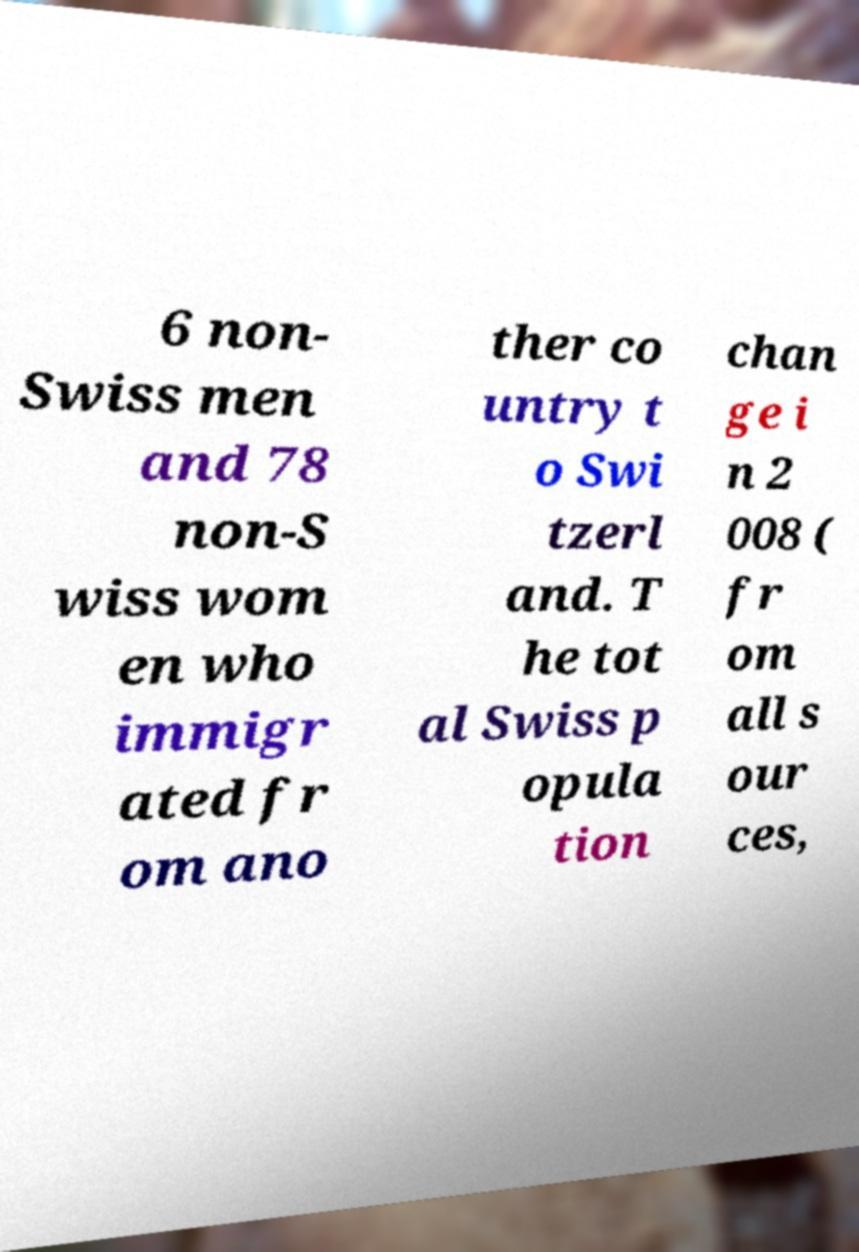Could you assist in decoding the text presented in this image and type it out clearly? 6 non- Swiss men and 78 non-S wiss wom en who immigr ated fr om ano ther co untry t o Swi tzerl and. T he tot al Swiss p opula tion chan ge i n 2 008 ( fr om all s our ces, 